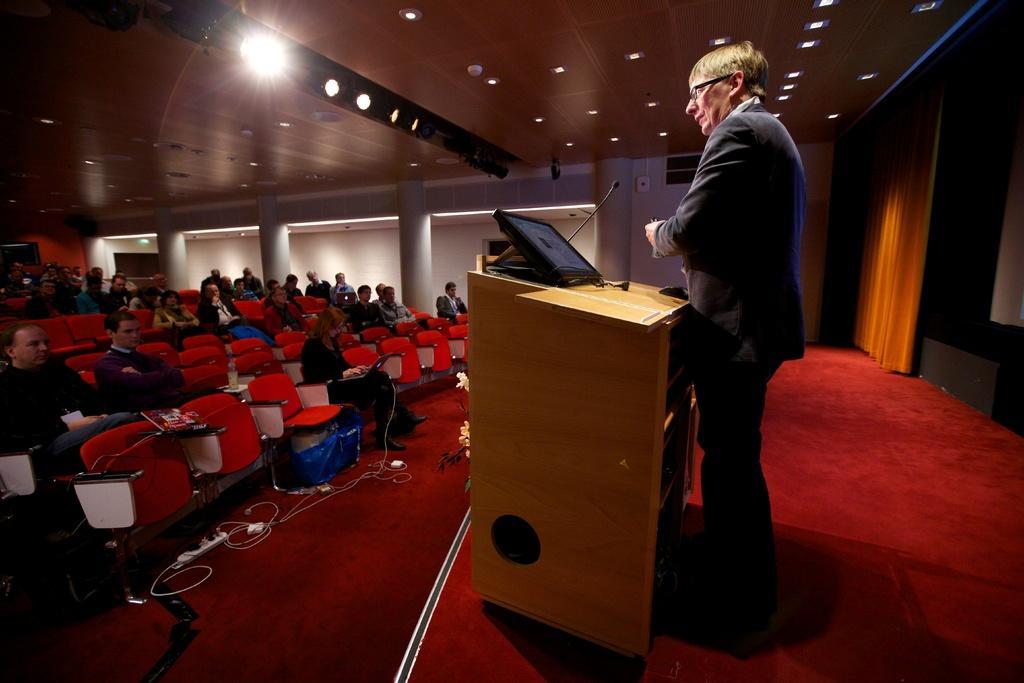How would you summarize this image in a sentence or two? In this image we can see a person wearing specs. He is standing. In front of him there is a podium. On the podium there is a screen and mic. On the right side there is curtain. On the ceiling there are lights. On the left side there are many people sitting on chairs. On the floor there is an extension board with wires. In the back there are pillars. 